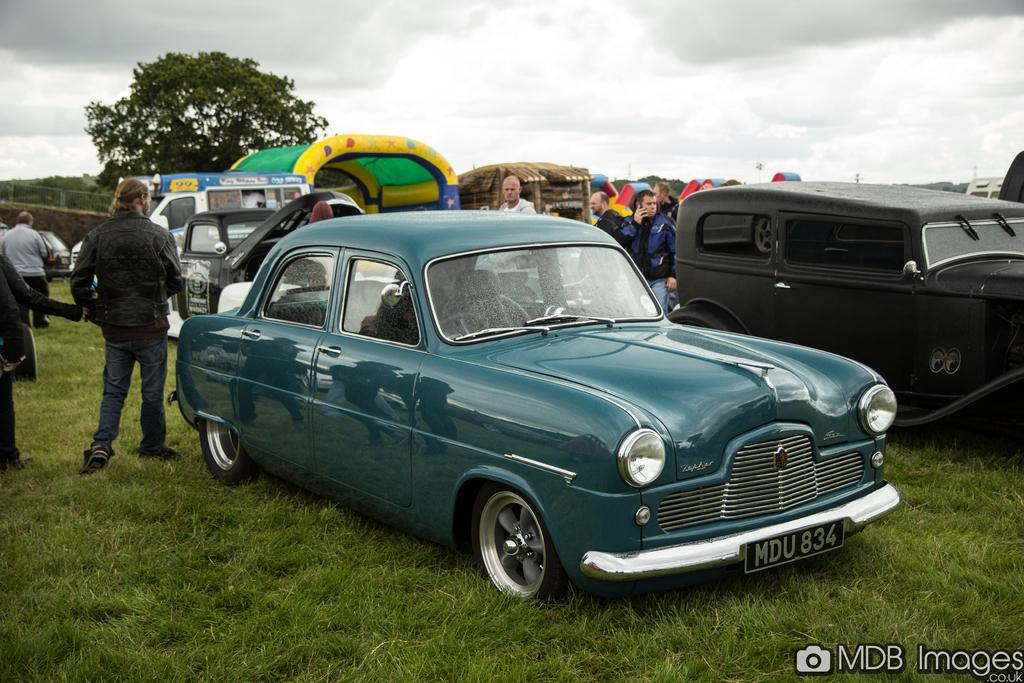<image>
Provide a brief description of the given image. A field with parked cars including one car with number plate MDU834. 